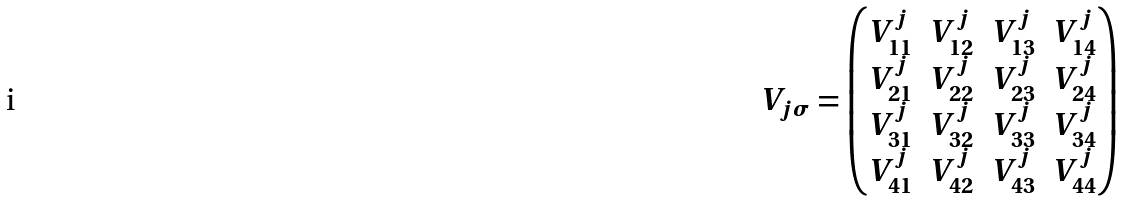<formula> <loc_0><loc_0><loc_500><loc_500>V _ { j \sigma } = \begin{pmatrix} V ^ { j } _ { 1 1 } & V ^ { j } _ { 1 2 } & V ^ { j } _ { 1 3 } & V ^ { j } _ { 1 4 } \\ V ^ { j } _ { 2 1 } & V ^ { j } _ { 2 2 } & V ^ { j } _ { 2 3 } & V ^ { j } _ { 2 4 } \\ V ^ { j } _ { 3 1 } & V ^ { j } _ { 3 2 } & V ^ { j } _ { 3 3 } & V ^ { j } _ { 3 4 } \\ V ^ { j } _ { 4 1 } & V ^ { j } _ { 4 2 } & V ^ { j } _ { 4 3 } & V ^ { j } _ { 4 4 } \end{pmatrix}</formula> 